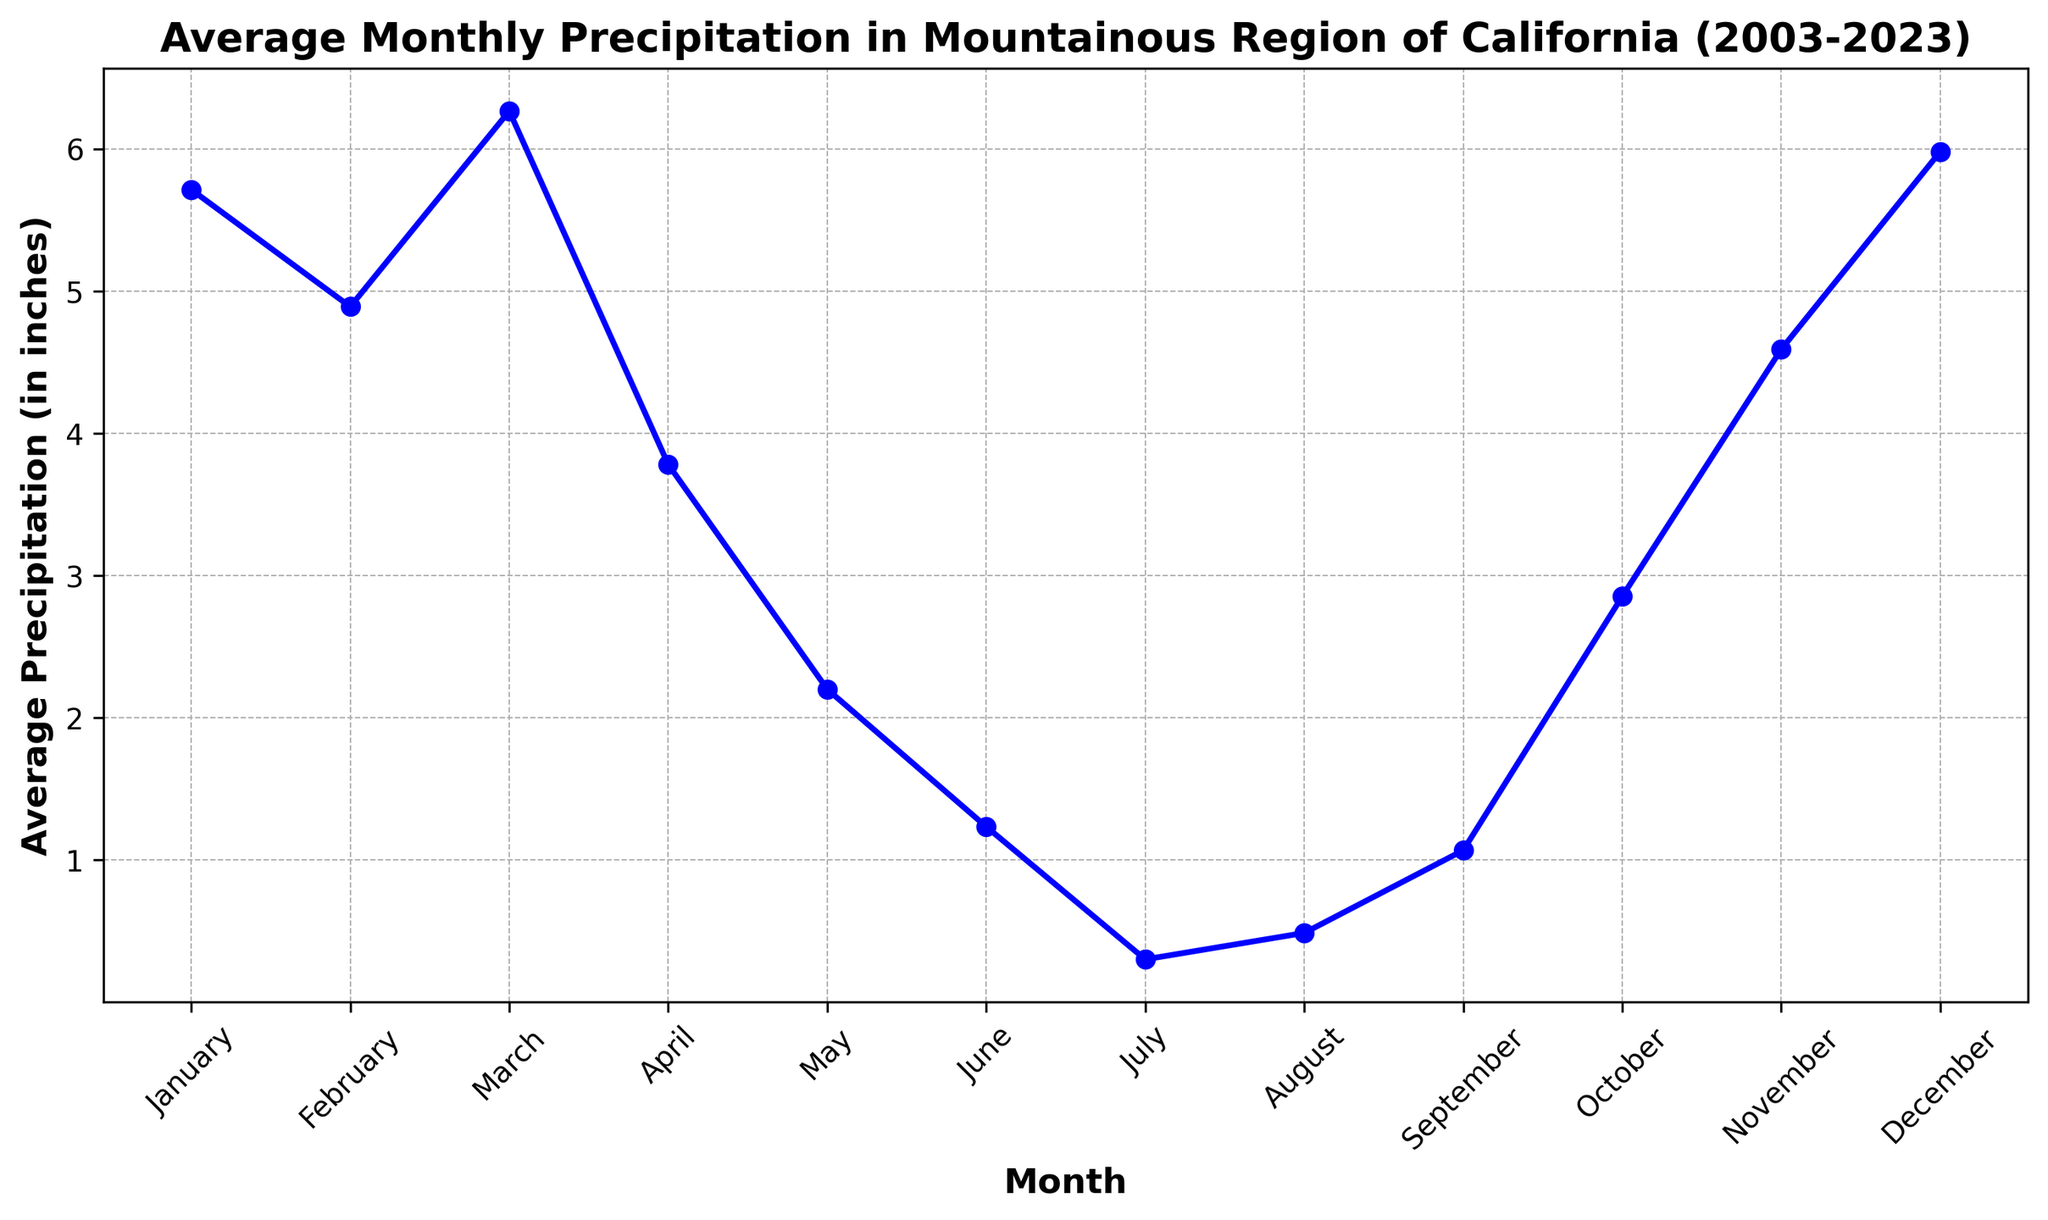Which month has the highest average precipitation? On the plot, identify the highest peak point along the y-axis corresponding to the month. The month with the highest marker will have the highest average precipitation.
Answer: December Which month has the lowest average precipitation? Find the lowest point on the plot along the y-axis. The month corresponding to this point is the month with the lowest average precipitation.
Answer: July Compare the average precipitation between March and April. Which month has more precipitation? Locate the markers for March and April on the x-axis, and compare their y-values (heights). The marker with the higher y-value signifies higher precipitation.
Answer: March What is the average precipitation difference between November and May? Find the y-values for both November and May. Subtract the May value from the November value.
Answer: 2.4 inches In which months does the average precipitation exceed 5 inches? Observe the y-axis and look for where the line crosses 5 inches. Identify the corresponding months on the x-axis where this occurs.
Answer: January, February, March, November, December What is the rank of June in terms of average precipitation from lowest to highest? Visually arrange the months in ascending order of their y-values and find where June stands in this sequence.
Answer: Fourth By how much does the average precipitation in February differ from that in August? Locate the y-values for both February and August. Subtract the August value from the February value.
Answer: 4.4 inches Which months have an average precipitation of approximately 1 inch? Identify the markers on the plot that are closest to the 1-inch mark on the y-axis and note their corresponding months.
Answer: June, July, August, September How does the average precipitation in January compare to that in October? Compare the heights of the points for January and October. January's point is significantly higher than October's point.
Answer: January is higher What is the overall trend in average precipitation from January to December? Observe the general movement of the line plot. Note the changes in y-values from January to December. The trend shows high values in the early and late months with a dip during the middle months.
Answer: Decreases from winter to summer, increases again toward winter 